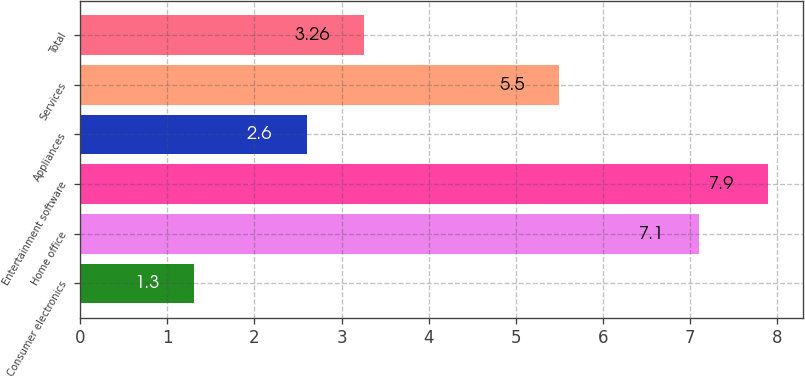<chart> <loc_0><loc_0><loc_500><loc_500><bar_chart><fcel>Consumer electronics<fcel>Home office<fcel>Entertainment software<fcel>Appliances<fcel>Services<fcel>Total<nl><fcel>1.3<fcel>7.1<fcel>7.9<fcel>2.6<fcel>5.5<fcel>3.26<nl></chart> 